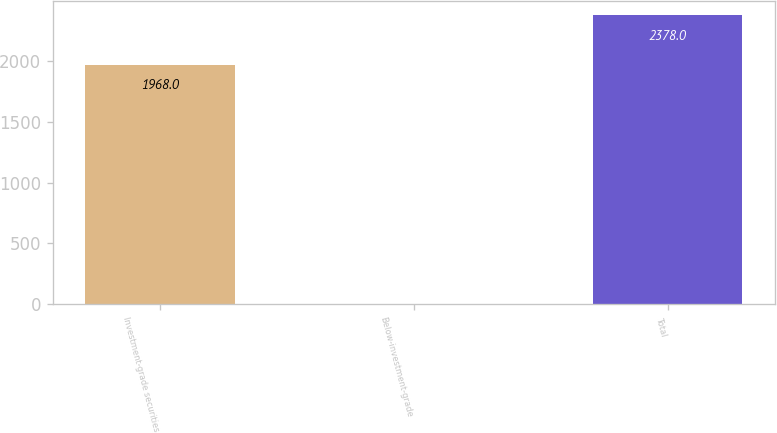Convert chart to OTSL. <chart><loc_0><loc_0><loc_500><loc_500><bar_chart><fcel>Investment-grade securities<fcel>Below-investment-grade<fcel>Total<nl><fcel>1968<fcel>2<fcel>2378<nl></chart> 